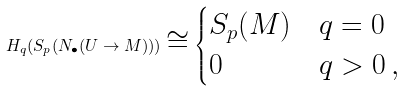<formula> <loc_0><loc_0><loc_500><loc_500>H _ { q } ( S _ { p } ( N _ { \bullet } ( U \to M ) ) ) \cong \begin{cases} S _ { p } ( M ) & q = 0 \\ 0 & q > 0 \, , \end{cases}</formula> 